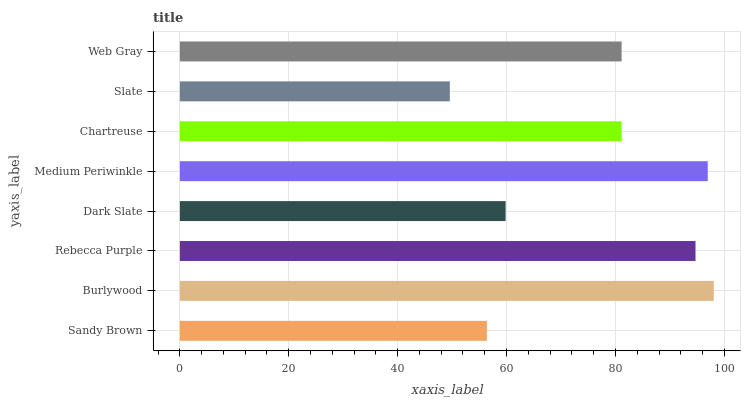Is Slate the minimum?
Answer yes or no. Yes. Is Burlywood the maximum?
Answer yes or no. Yes. Is Rebecca Purple the minimum?
Answer yes or no. No. Is Rebecca Purple the maximum?
Answer yes or no. No. Is Burlywood greater than Rebecca Purple?
Answer yes or no. Yes. Is Rebecca Purple less than Burlywood?
Answer yes or no. Yes. Is Rebecca Purple greater than Burlywood?
Answer yes or no. No. Is Burlywood less than Rebecca Purple?
Answer yes or no. No. Is Chartreuse the high median?
Answer yes or no. Yes. Is Web Gray the low median?
Answer yes or no. Yes. Is Rebecca Purple the high median?
Answer yes or no. No. Is Rebecca Purple the low median?
Answer yes or no. No. 